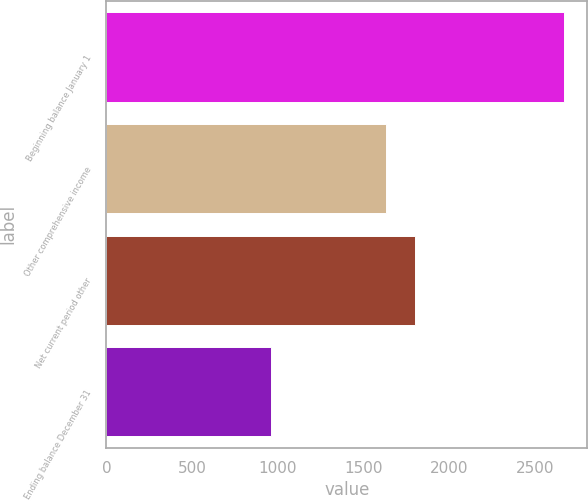<chart> <loc_0><loc_0><loc_500><loc_500><bar_chart><fcel>Beginning balance January 1<fcel>Other comprehensive income<fcel>Net current period other<fcel>Ending balance December 31<nl><fcel>2669<fcel>1629<fcel>1800.2<fcel>957<nl></chart> 